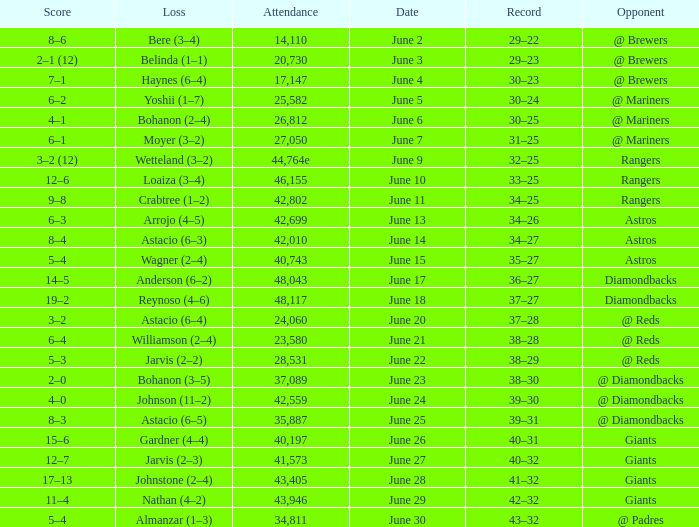What's the record when the attendance was 41,573? 40–32. 